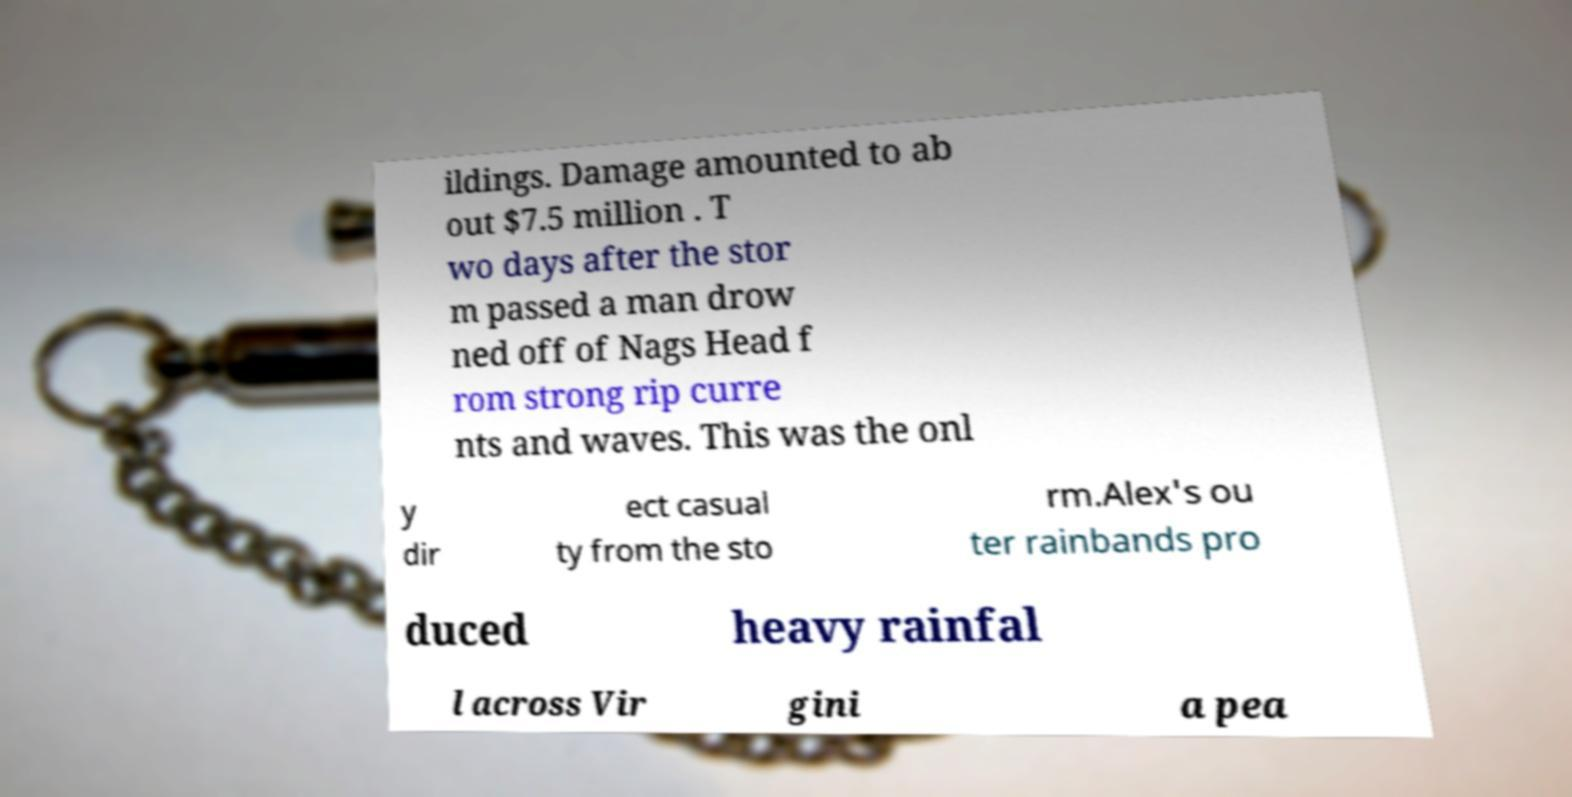For documentation purposes, I need the text within this image transcribed. Could you provide that? ildings. Damage amounted to ab out $7.5 million . T wo days after the stor m passed a man drow ned off of Nags Head f rom strong rip curre nts and waves. This was the onl y dir ect casual ty from the sto rm.Alex's ou ter rainbands pro duced heavy rainfal l across Vir gini a pea 